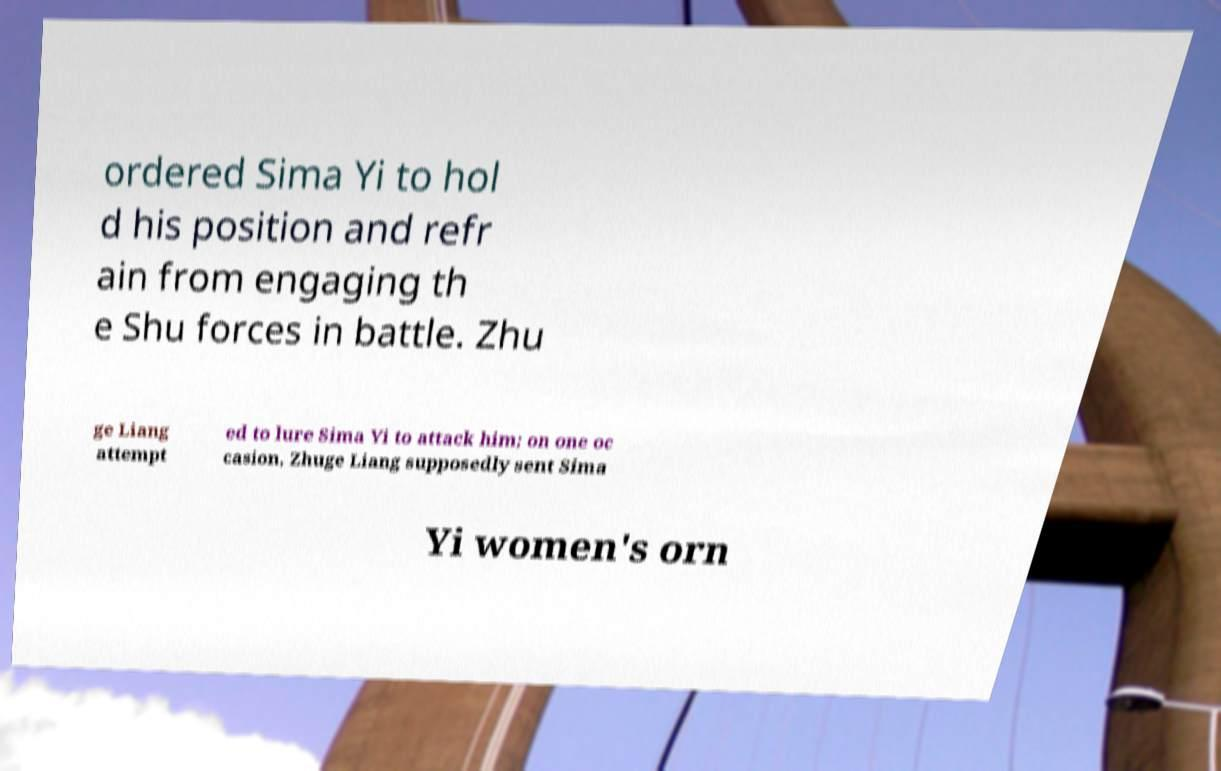Please identify and transcribe the text found in this image. ordered Sima Yi to hol d his position and refr ain from engaging th e Shu forces in battle. Zhu ge Liang attempt ed to lure Sima Yi to attack him; on one oc casion, Zhuge Liang supposedly sent Sima Yi women's orn 